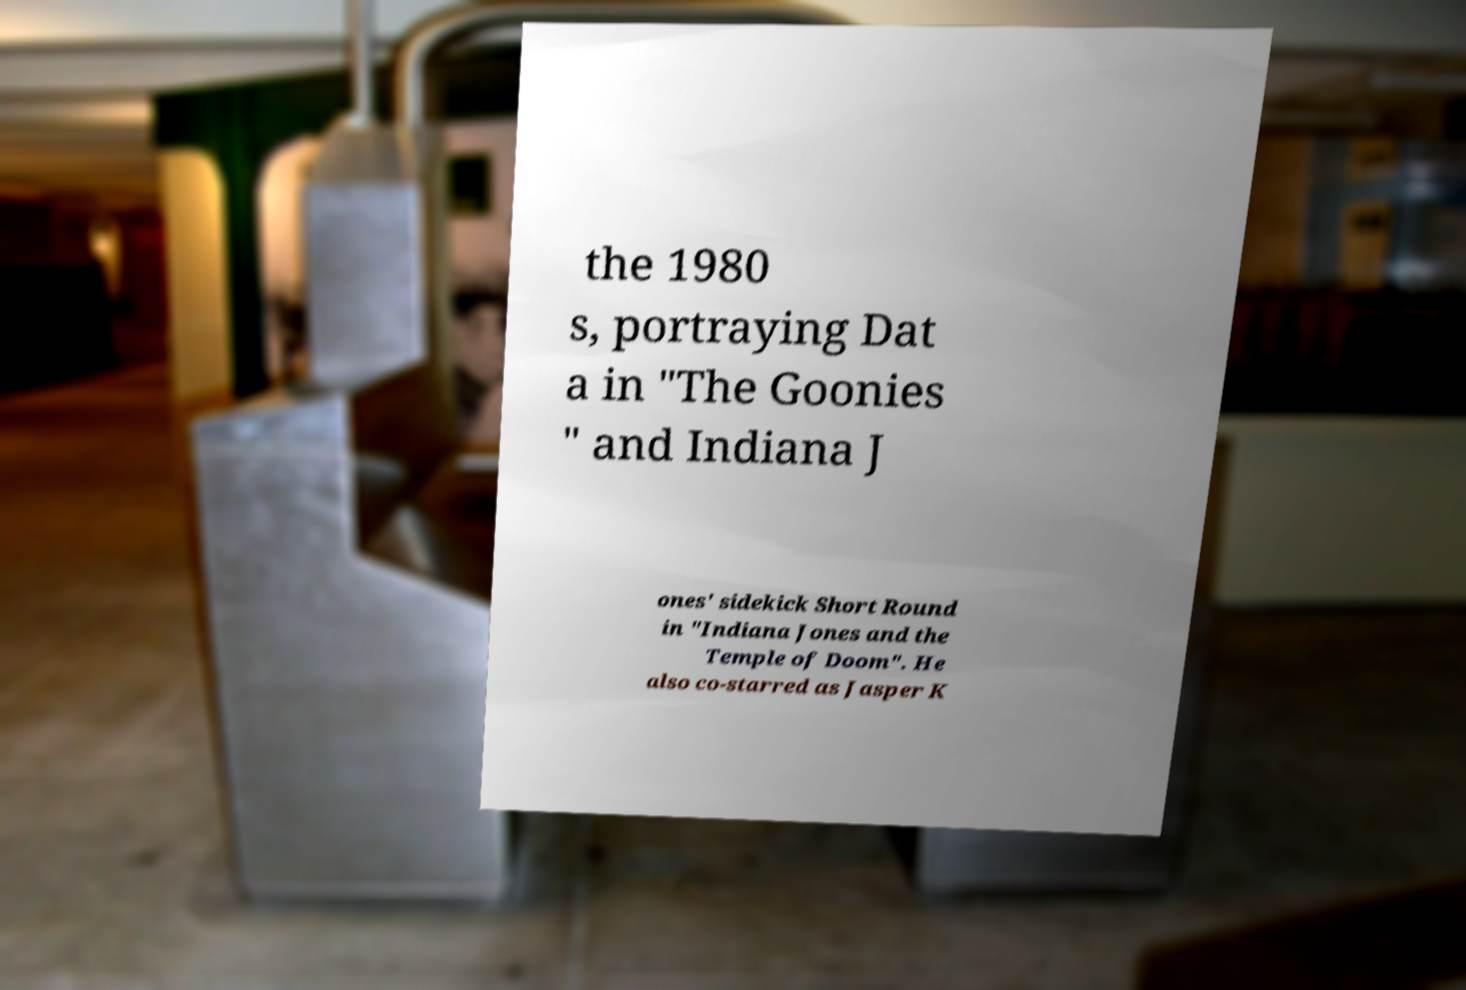Could you assist in decoding the text presented in this image and type it out clearly? the 1980 s, portraying Dat a in "The Goonies " and Indiana J ones' sidekick Short Round in "Indiana Jones and the Temple of Doom". He also co-starred as Jasper K 